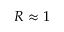Convert formula to latex. <formula><loc_0><loc_0><loc_500><loc_500>R \approx 1</formula> 